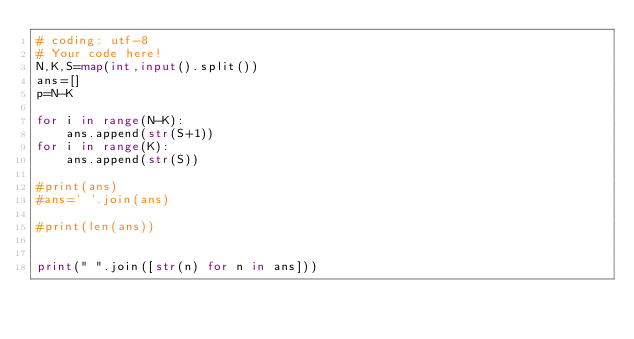Convert code to text. <code><loc_0><loc_0><loc_500><loc_500><_Python_># coding: utf-8
# Your code here!
N,K,S=map(int,input().split())
ans=[]
p=N-K

for i in range(N-K):
    ans.append(str(S+1))
for i in range(K):
    ans.append(str(S))

#print(ans)
#ans=' '.join(ans)

#print(len(ans))


print(" ".join([str(n) for n in ans]))</code> 